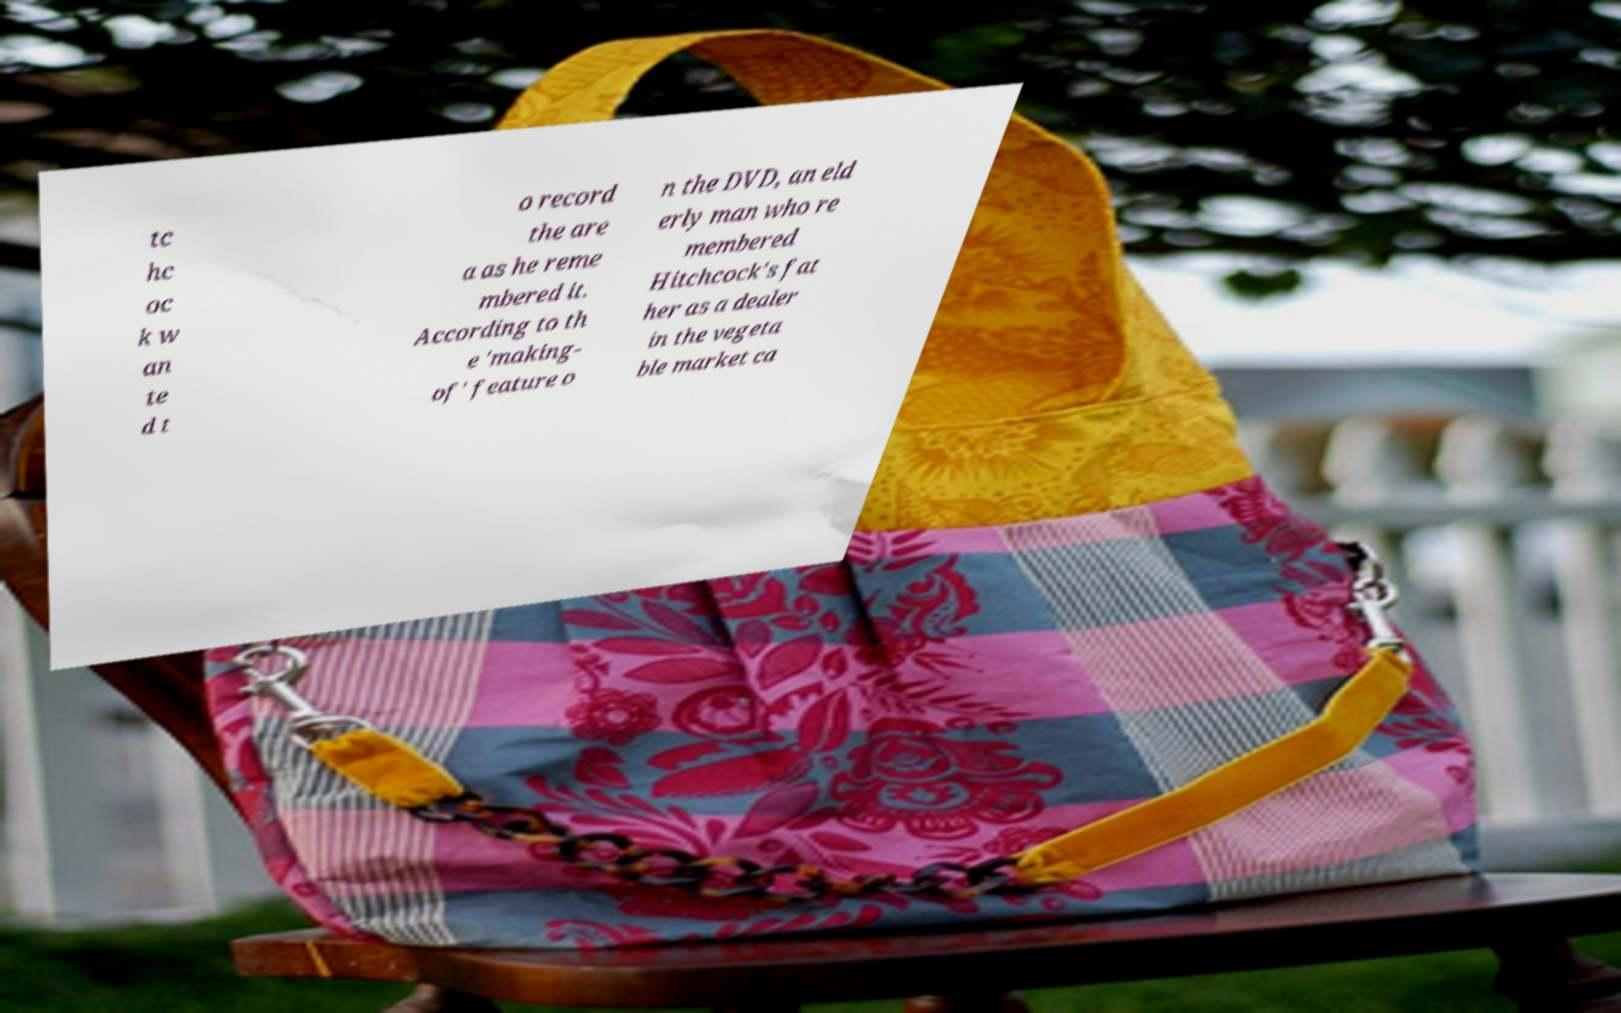Could you extract and type out the text from this image? tc hc oc k w an te d t o record the are a as he reme mbered it. According to th e 'making- of' feature o n the DVD, an eld erly man who re membered Hitchcock's fat her as a dealer in the vegeta ble market ca 